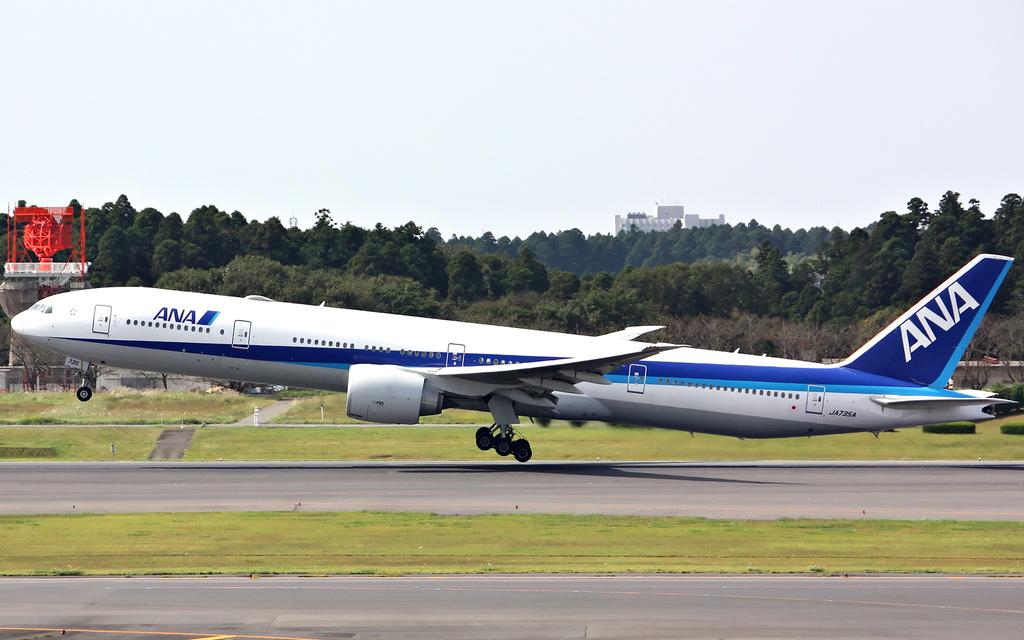Which airline is this?
Provide a short and direct response. Ana. What is the registration number of the plane?
Ensure brevity in your answer.  Ja735a. 